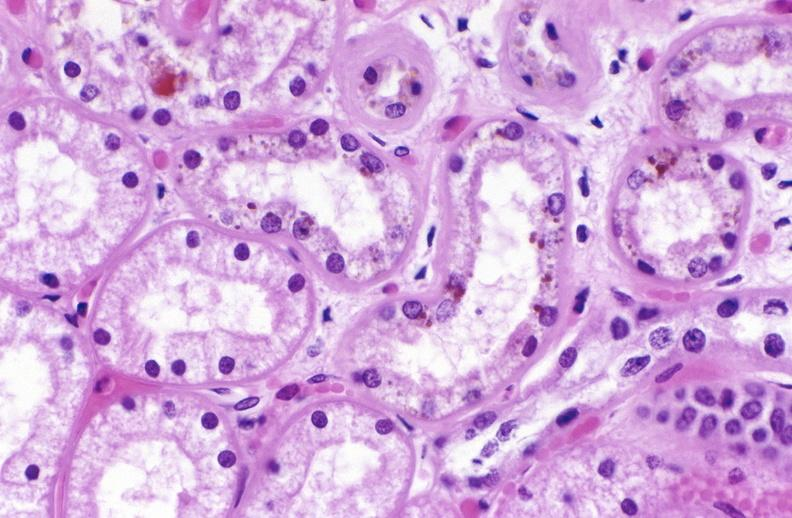what does this image show?
Answer the question using a single word or phrase. Atn and bile pigment 